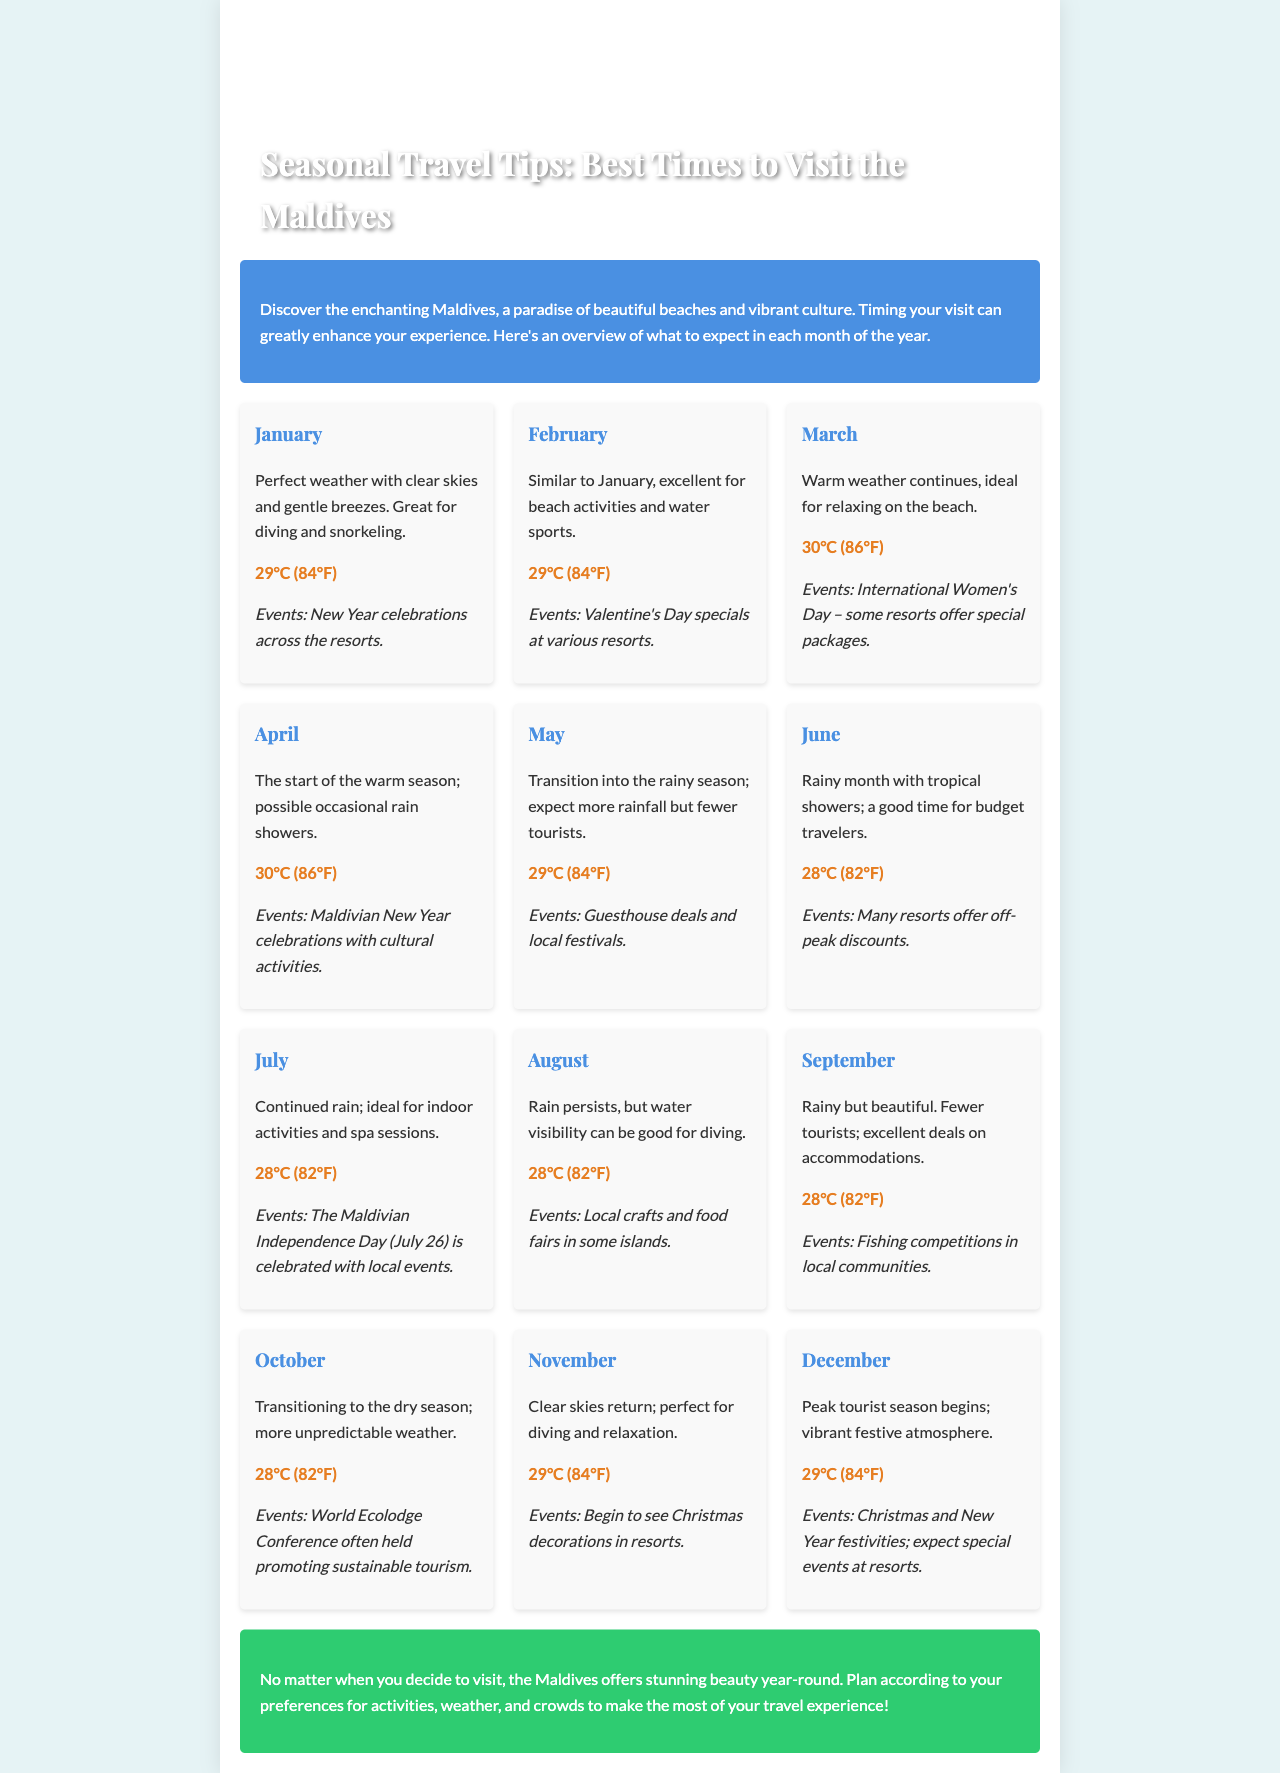what is the temperature in January? The document states that the temperature in January is 29°C (84°F).
Answer: 29°C (84°F) what events occur in February? It mentions Valentine's Day specials at various resorts as the event in February.
Answer: Valentine's Day specials which month marks the start of the rainy season? The document indicates that May is the month when the transition into the rainy season begins.
Answer: May what is noted about October's weather? The document notes that October has more unpredictable weather as it transitions to the dry season.
Answer: Unpredictable weather which month is described as having a peak tourist season? December is identified as the month when the peak tourist season begins.
Answer: December in which month can you find ideal conditions for diving and relaxation? The document states that November is perfect for diving and relaxation.
Answer: November how many degrees does the temperature drop from January to June? The temperature drops from 29°C (84°F) in January to 28°C (82°F) in June, which is a decrease of 1°C.
Answer: 1°C what types of activities are recommended in July? The document recommends indoor activities and spa sessions for July due to continuing rain.
Answer: Indoor activities and spa sessions what is the significance of Maldives Independence Day? The document states that Maldivian Independence Day is celebrated on July 26 with local events.
Answer: Local events 